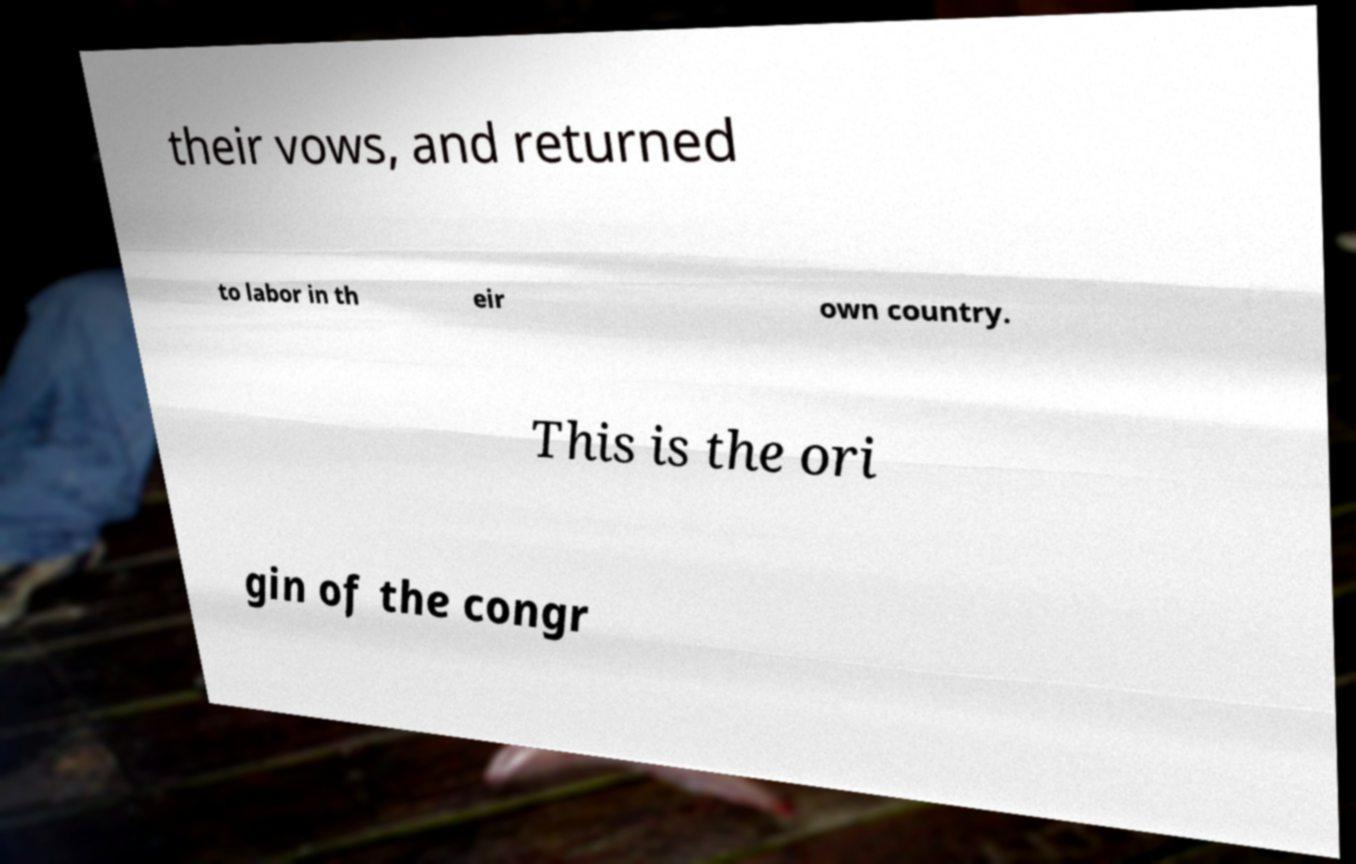For documentation purposes, I need the text within this image transcribed. Could you provide that? their vows, and returned to labor in th eir own country. This is the ori gin of the congr 